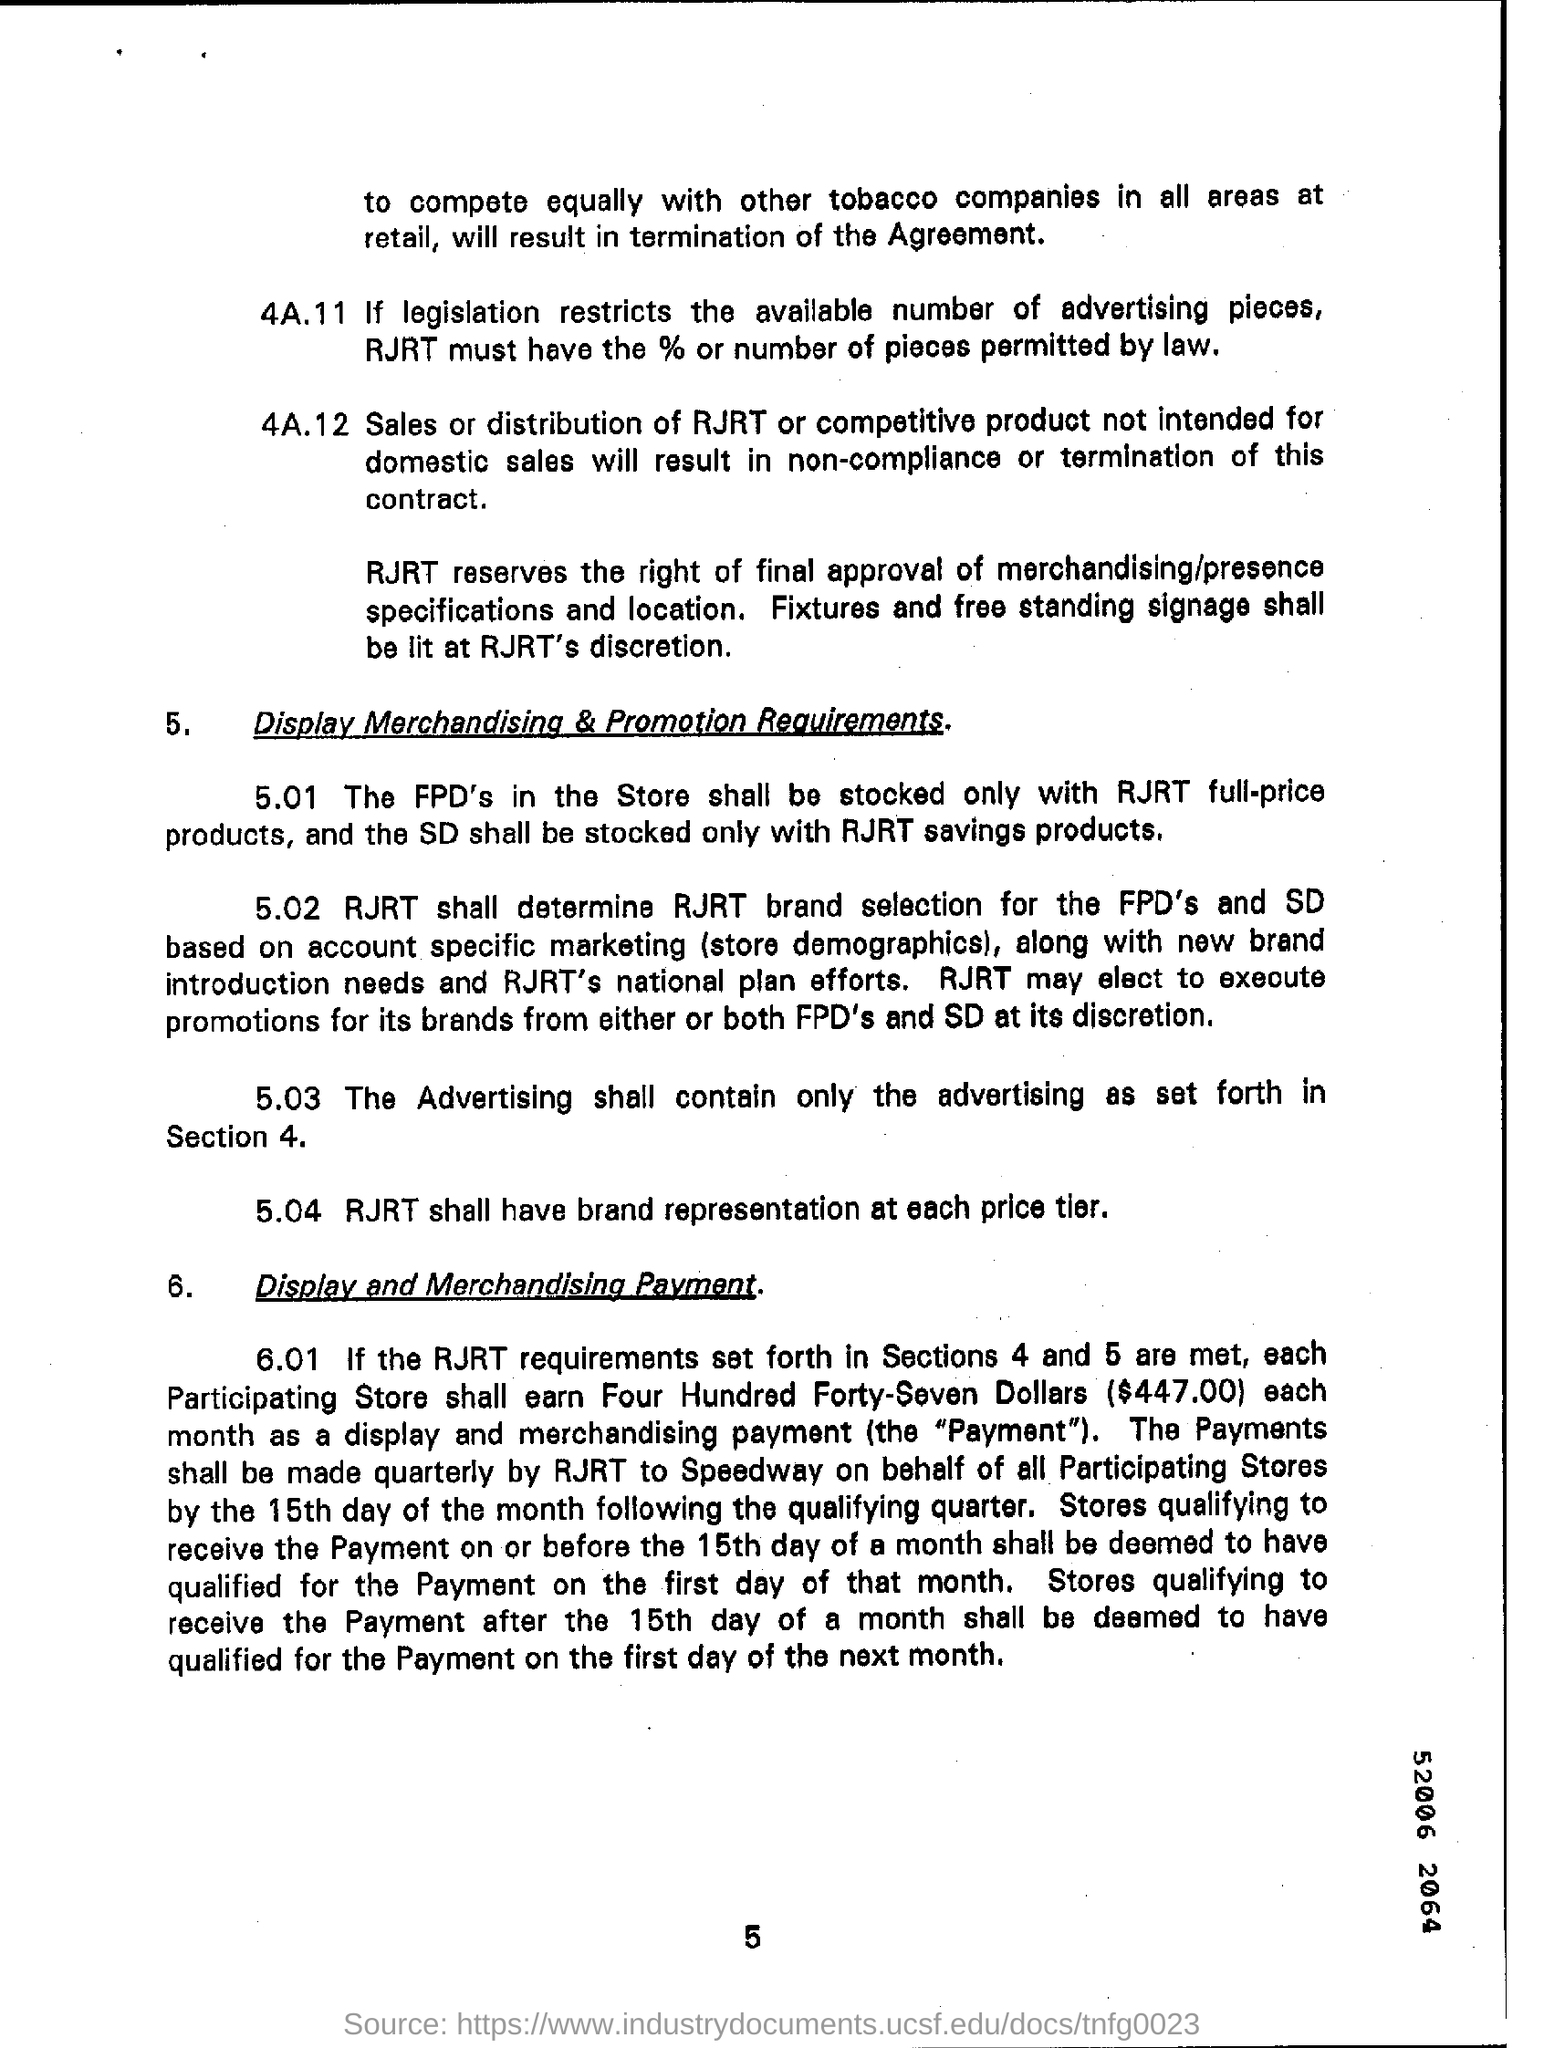Give some essential details in this illustration. The page number written on the bottom is 5. 